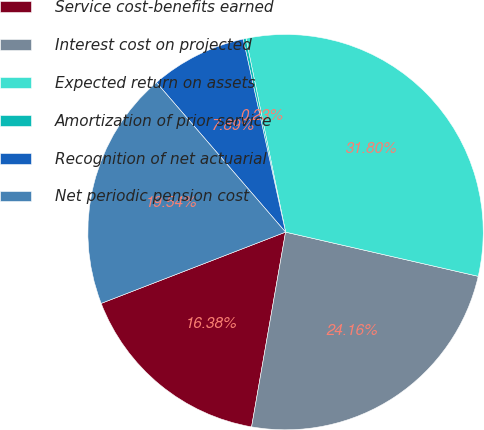Convert chart. <chart><loc_0><loc_0><loc_500><loc_500><pie_chart><fcel>Service cost-benefits earned<fcel>Interest cost on projected<fcel>Expected return on assets<fcel>Amortization of prior service<fcel>Recognition of net actuarial<fcel>Net periodic pension cost<nl><fcel>16.38%<fcel>24.16%<fcel>31.8%<fcel>0.23%<fcel>7.89%<fcel>19.54%<nl></chart> 